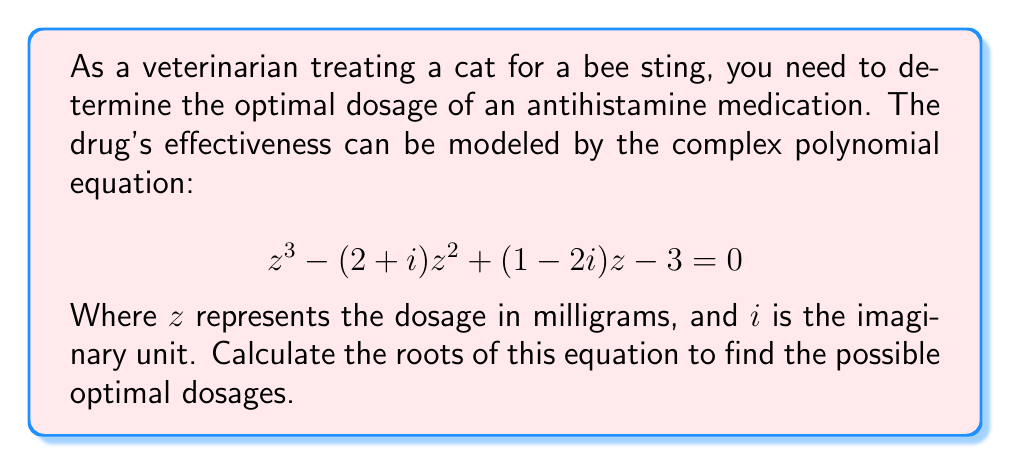Show me your answer to this math problem. To solve this cubic equation, we can use the following steps:

1) First, we need to identify the coefficients:
   $a = 1$
   $b = -(2+i)$
   $c = 1-2i$
   $d = -3$

2) Calculate the following intermediate values:
   $p = \frac{3ac-b^2}{3a^2} = \frac{3(1)(1-2i)-(-(2+i))^2}{3(1)^2} = \frac{3-6i-(4+4i+i^2)}{3} = \frac{-2-10i}{3}$
   
   $q = \frac{2b^3-9abc+27a^2d}{27a^3} = \frac{2(-(2+i))^3-9(1)(-(2+i))(1-2i)+27(1)^2(-3)}{27(1)^3}$
   $= \frac{-2(-8-12i+6i^2+i^3)+9(2+i)(1-2i)-81}{27} = \frac{16+24i-12-2i+18+9i-36i-81}{27} = \frac{-59-5i}{27}$

3) Calculate the discriminant:
   $D = (\frac{q}{2})^2 + (\frac{p}{3})^3 = (\frac{-59-5i}{54})^2 + (\frac{-2-10i}{9})^3$

4) Calculate the cube roots:
   $u = \sqrt[3]{-\frac{q}{2} + \sqrt{D}}$
   $v = \sqrt[3]{-\frac{q}{2} - \sqrt{D}}$

5) The roots are given by:
   $z_1 = u + v + \frac{b}{3a}$
   $z_2 = \omega u + \omega^2 v + \frac{b}{3a}$
   $z_3 = \omega^2 u + \omega v + \frac{b}{3a}$

   Where $\omega = -\frac{1}{2} + i\frac{\sqrt{3}}{2}$ is a cube root of unity.

6) Simplify and calculate the numerical values of these roots.
Answer: The roots of the equation, representing the possible optimal dosages, are:

$z_1 \approx 2.8951 + 0.4362i$ mg
$z_2 \approx -0.6976 + 0.8319i$ mg
$z_3 \approx -0.1975 - 0.2681i$ mg

Note: The imaginary parts of these solutions indicate that they are not practical dosages. In a real-world scenario, we would need to interpret these results and possibly adjust our model or constraints. 